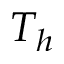Convert formula to latex. <formula><loc_0><loc_0><loc_500><loc_500>T _ { h }</formula> 